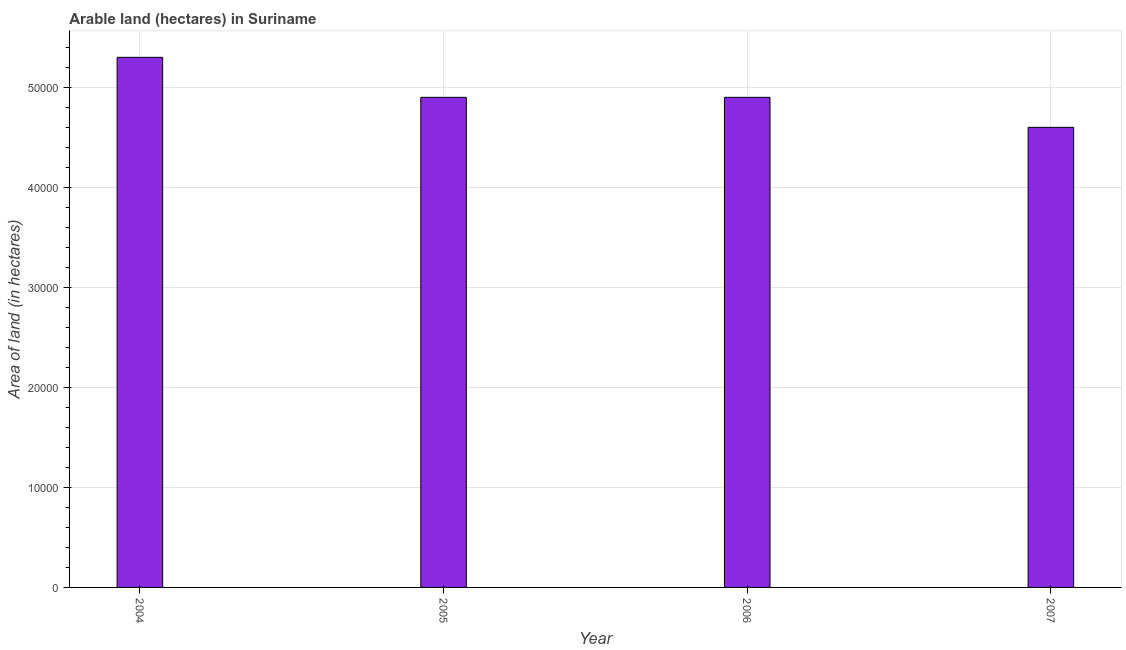Does the graph contain grids?
Make the answer very short. Yes. What is the title of the graph?
Provide a succinct answer. Arable land (hectares) in Suriname. What is the label or title of the X-axis?
Your answer should be very brief. Year. What is the label or title of the Y-axis?
Keep it short and to the point. Area of land (in hectares). What is the area of land in 2007?
Ensure brevity in your answer.  4.60e+04. Across all years, what is the maximum area of land?
Your answer should be compact. 5.30e+04. Across all years, what is the minimum area of land?
Provide a short and direct response. 4.60e+04. In which year was the area of land minimum?
Make the answer very short. 2007. What is the sum of the area of land?
Provide a succinct answer. 1.97e+05. What is the difference between the area of land in 2005 and 2007?
Provide a succinct answer. 3000. What is the average area of land per year?
Keep it short and to the point. 4.92e+04. What is the median area of land?
Provide a short and direct response. 4.90e+04. In how many years, is the area of land greater than 46000 hectares?
Offer a very short reply. 3. Do a majority of the years between 2004 and 2005 (inclusive) have area of land greater than 8000 hectares?
Offer a very short reply. Yes. Is the difference between the area of land in 2004 and 2006 greater than the difference between any two years?
Provide a short and direct response. No. What is the difference between the highest and the second highest area of land?
Give a very brief answer. 4000. What is the difference between the highest and the lowest area of land?
Offer a terse response. 7000. In how many years, is the area of land greater than the average area of land taken over all years?
Your response must be concise. 1. How many bars are there?
Make the answer very short. 4. Are all the bars in the graph horizontal?
Provide a succinct answer. No. How many years are there in the graph?
Make the answer very short. 4. What is the difference between two consecutive major ticks on the Y-axis?
Your response must be concise. 10000. What is the Area of land (in hectares) in 2004?
Your response must be concise. 5.30e+04. What is the Area of land (in hectares) of 2005?
Ensure brevity in your answer.  4.90e+04. What is the Area of land (in hectares) in 2006?
Your answer should be very brief. 4.90e+04. What is the Area of land (in hectares) of 2007?
Your answer should be compact. 4.60e+04. What is the difference between the Area of land (in hectares) in 2004 and 2005?
Offer a very short reply. 4000. What is the difference between the Area of land (in hectares) in 2004 and 2006?
Keep it short and to the point. 4000. What is the difference between the Area of land (in hectares) in 2004 and 2007?
Keep it short and to the point. 7000. What is the difference between the Area of land (in hectares) in 2005 and 2006?
Provide a succinct answer. 0. What is the difference between the Area of land (in hectares) in 2005 and 2007?
Provide a succinct answer. 3000. What is the difference between the Area of land (in hectares) in 2006 and 2007?
Ensure brevity in your answer.  3000. What is the ratio of the Area of land (in hectares) in 2004 to that in 2005?
Provide a short and direct response. 1.08. What is the ratio of the Area of land (in hectares) in 2004 to that in 2006?
Make the answer very short. 1.08. What is the ratio of the Area of land (in hectares) in 2004 to that in 2007?
Make the answer very short. 1.15. What is the ratio of the Area of land (in hectares) in 2005 to that in 2006?
Make the answer very short. 1. What is the ratio of the Area of land (in hectares) in 2005 to that in 2007?
Provide a short and direct response. 1.06. What is the ratio of the Area of land (in hectares) in 2006 to that in 2007?
Your answer should be very brief. 1.06. 